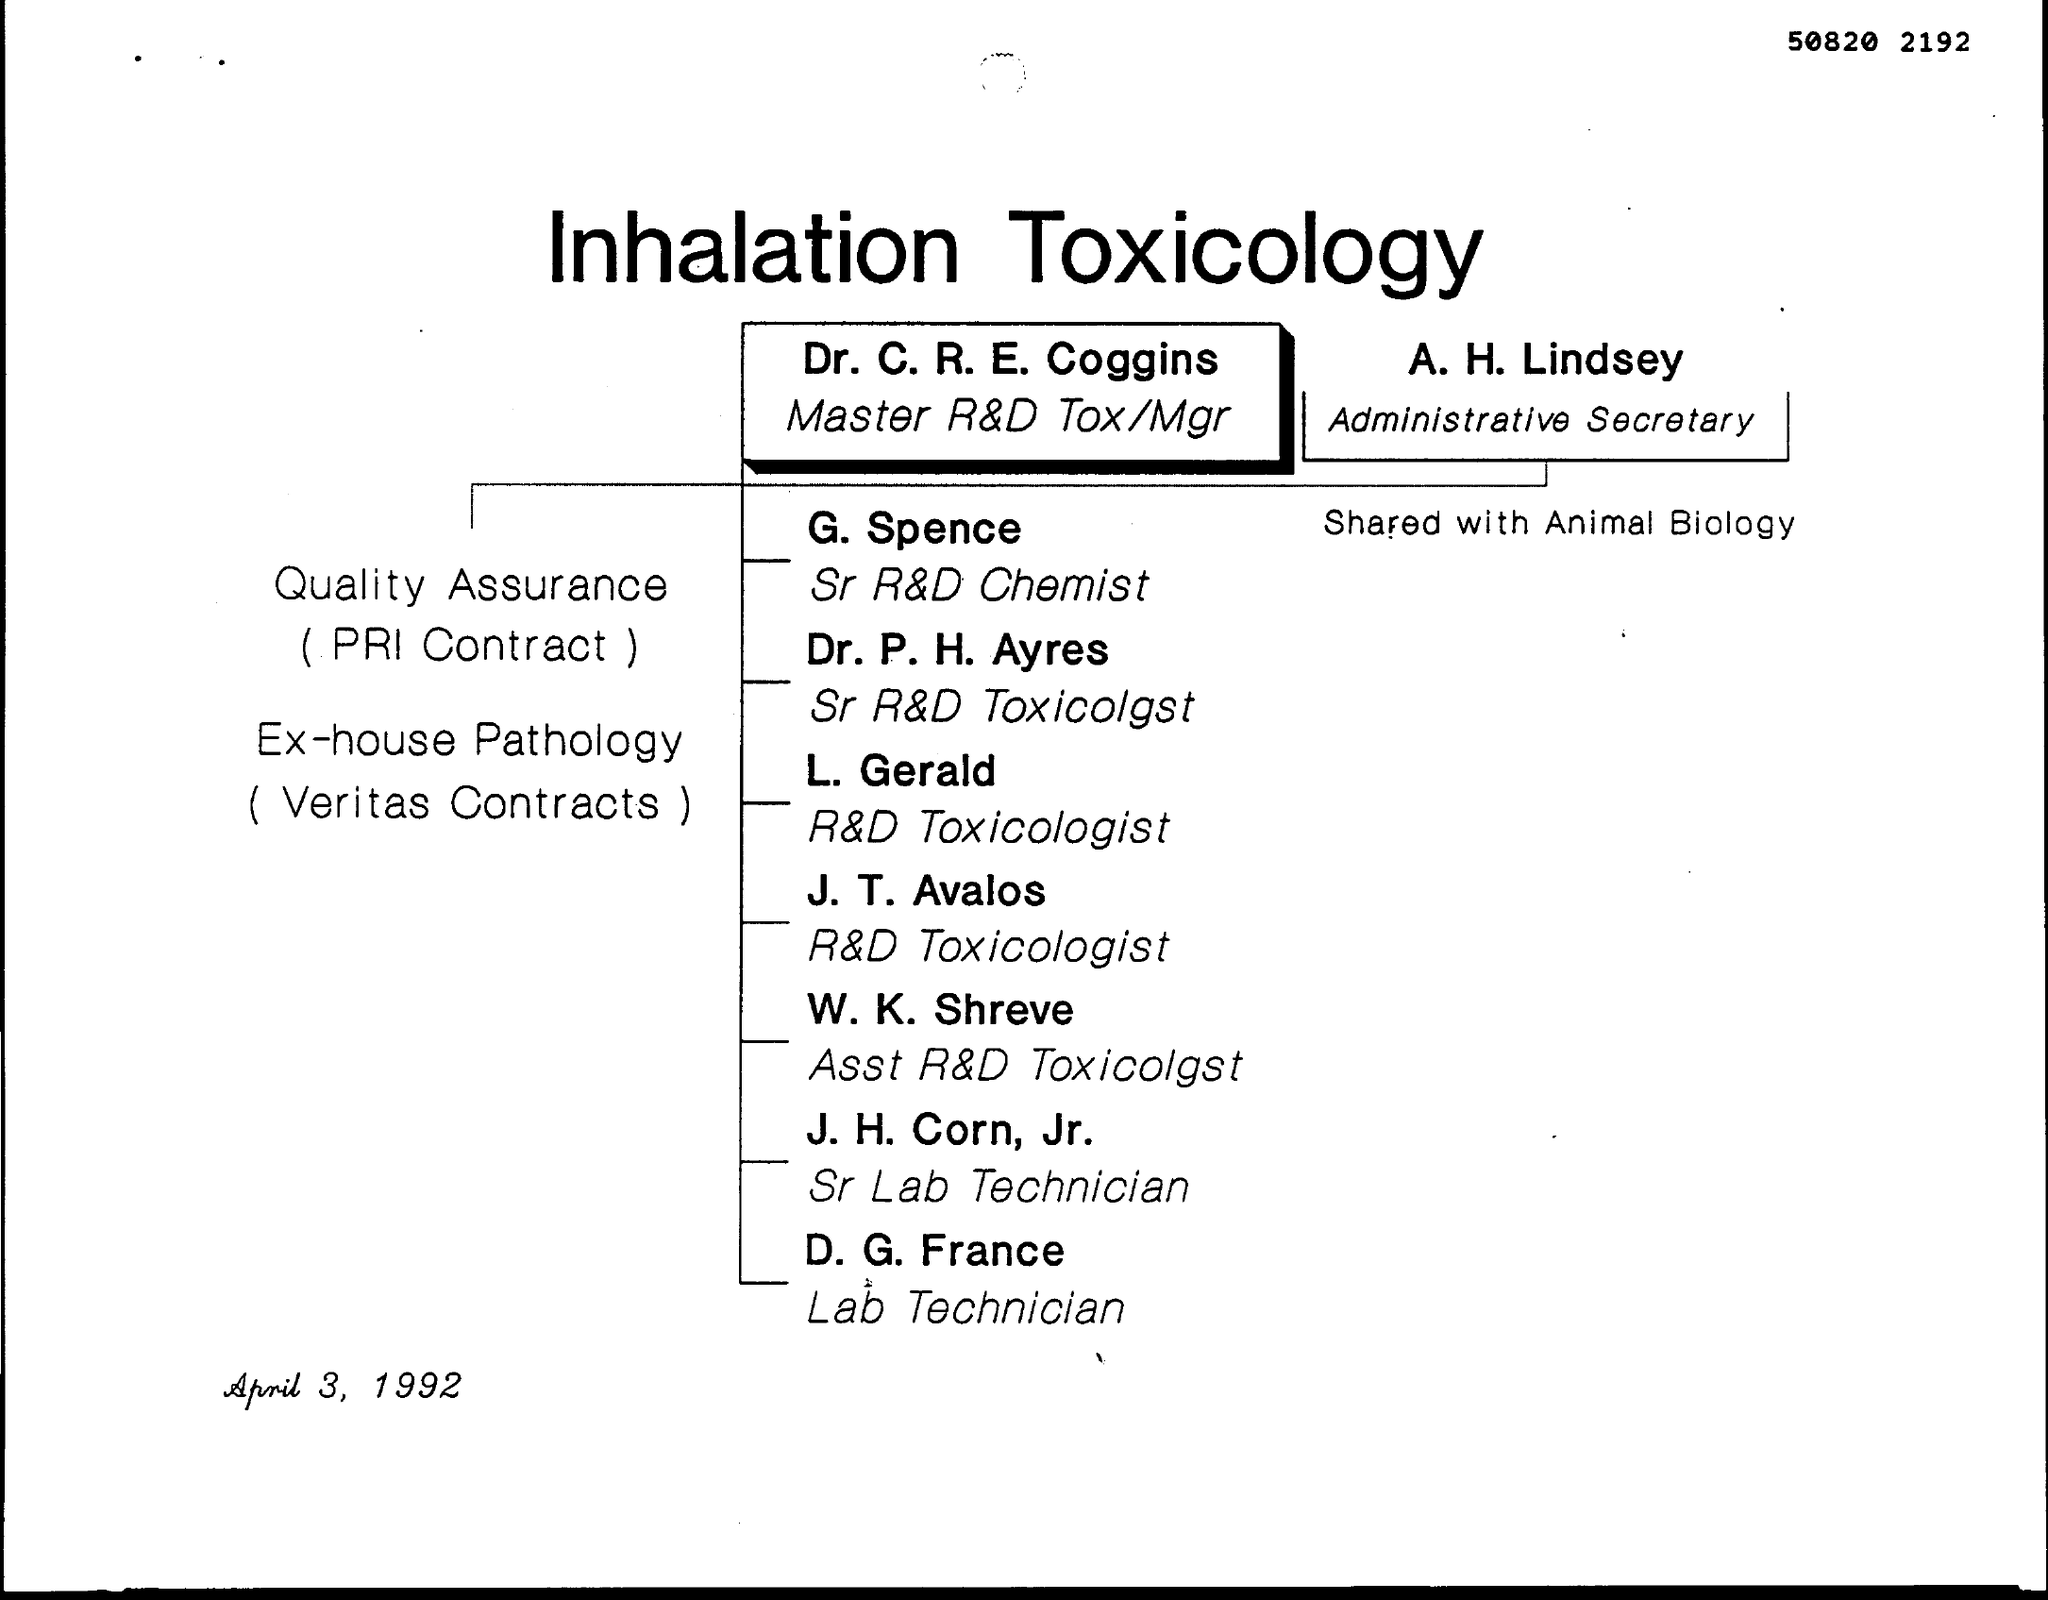What is the number written at the top of the page?
Give a very brief answer. 50820 2192. What is the document title?
Your answer should be compact. Inhalation Toxicology. What is the designation of Dr. C. R. E. Coggins??
Offer a terse response. Master R&D Tox/Mgr. Who is the Administrative Secretary?
Offer a terse response. A. H. Lindsey. When is the document dated?
Your response must be concise. April 3, 1992. 